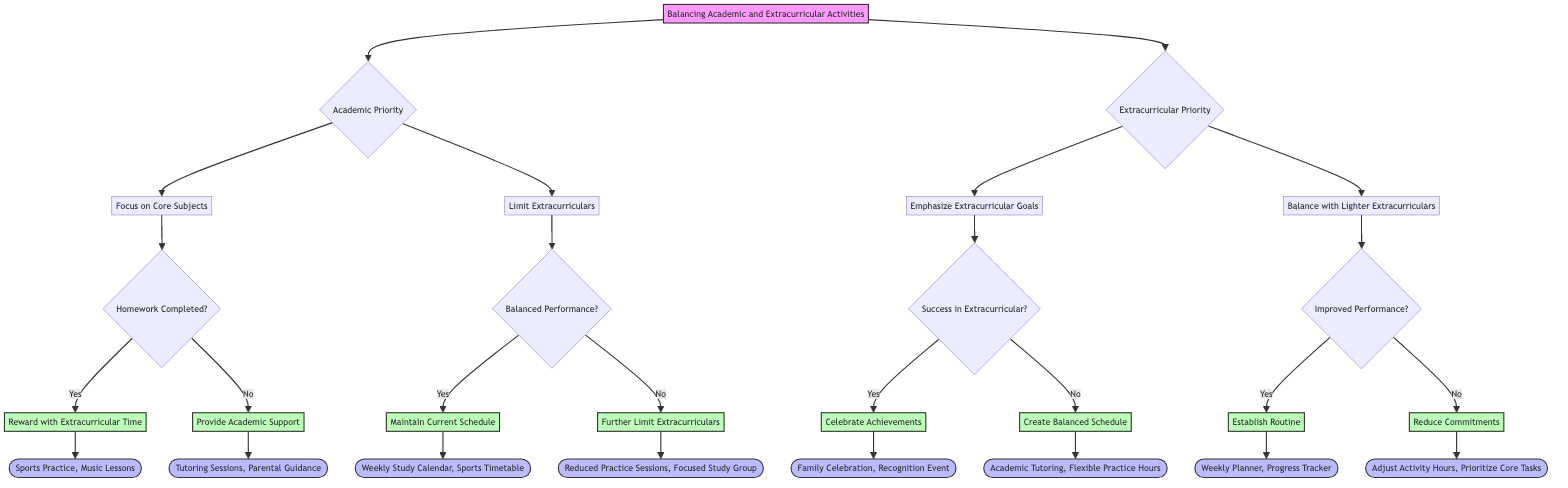What are the two main priorities in the diagram? The diagram indicates two main priorities: Academic Priority and Extracurricular Priority. These priorities branch out from the main node, showing the focus options for balancing activities.
Answer: Academic Priority, Extracurricular Priority What actions are suggested if homework is completed? If homework is completed, the diagram suggests rewarding the student with extracurricular time and encouraging leisure activities. This is the outcome from the homework completion condition under the focus on core subjects.
Answer: Reward with Extracurricular Time, Encourage Leisure Activities How many outcomes are there under the 'Limit Extracurriculars' action? Under the 'Limit Extracurriculars' action, there are two outcomes based on the balanced performance condition: Balanced Performance and Academic Decline.
Answer: 2 What is the next action if there is a struggle in academics after emphasizing extracurricular goals? If there is a struggle in academics after emphasizing extracurricular goals, the next action recommended is to create a balanced schedule involving academic tutoring and flexible practice hours. This is indicated under the struggle in academics condition.
Answer: Create Balanced Schedule Which outcome suggests to reduce commitments if the schedule is overwhelming? The outcome that suggests reducing commitments if the schedule is overwhelming is to reduce commitments and provide emotional support, involving adjusting activity hours and parental guidance. This follows from the overwhelming schedule condition under balancing with lighter extracurriculars.
Answer: Reduce Commitments, Provide Emotional Support What action is recommended if homework is incomplete? If homework is incomplete, the recommended action is to provide academic support, which includes tutoring sessions and parental guidance. This outcome is derived from the homework incomplete condition under the focus on core subjects.
Answer: Provide Academic Support What should a parent do if their teenager achieves success in extracurriculars? If a teenager achieves success in extracurriculars, the parent is encouraged to celebrate achievements and moderate more practice, which involves family celebration and recognition events. This is the action derived from the success in extracurricular condition.
Answer: Celebrate Achievements, Moderate More Practice What is indicated as a primary condition for maintaining the current schedule? The primary condition for maintaining the current schedule is balanced performance, which indicates that the balance between academics and extracurriculars is satisfactory.
Answer: Balanced Performance 